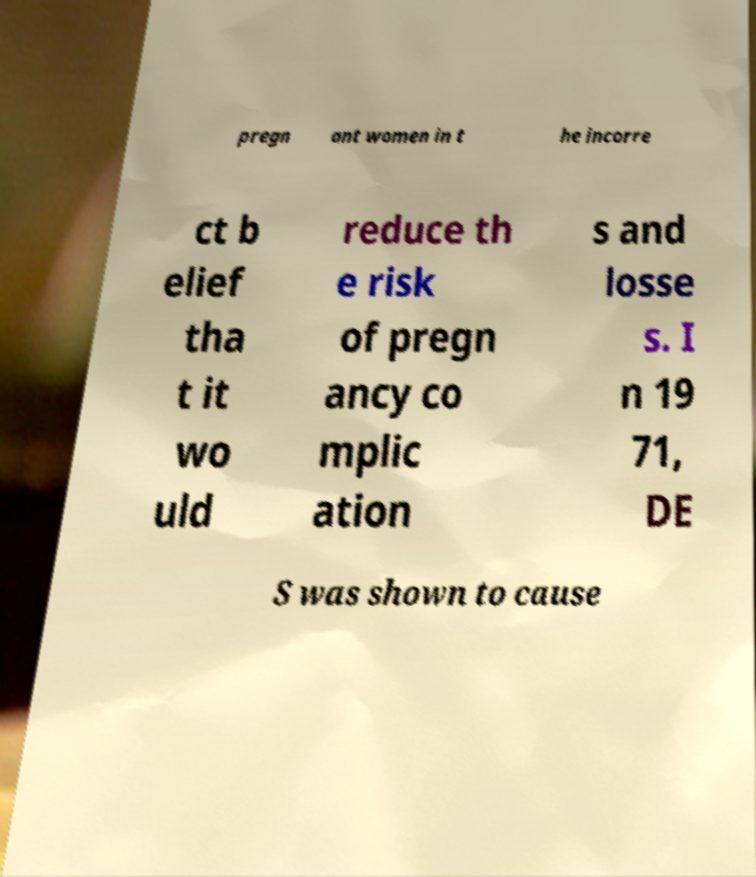Please identify and transcribe the text found in this image. pregn ant women in t he incorre ct b elief tha t it wo uld reduce th e risk of pregn ancy co mplic ation s and losse s. I n 19 71, DE S was shown to cause 